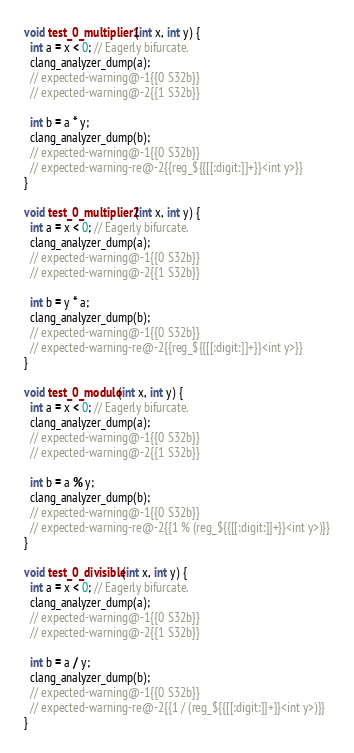<code> <loc_0><loc_0><loc_500><loc_500><_C_>void test_0_multiplier1(int x, int y) {
  int a = x < 0; // Eagerly bifurcate.
  clang_analyzer_dump(a);
  // expected-warning@-1{{0 S32b}}
  // expected-warning@-2{{1 S32b}}

  int b = a * y;
  clang_analyzer_dump(b);
  // expected-warning@-1{{0 S32b}}
  // expected-warning-re@-2{{reg_${{[[:digit:]]+}}<int y>}}
}

void test_0_multiplier2(int x, int y) {
  int a = x < 0; // Eagerly bifurcate.
  clang_analyzer_dump(a);
  // expected-warning@-1{{0 S32b}}
  // expected-warning@-2{{1 S32b}}

  int b = y * a;
  clang_analyzer_dump(b);
  // expected-warning@-1{{0 S32b}}
  // expected-warning-re@-2{{reg_${{[[:digit:]]+}}<int y>}}
}

void test_0_modulo(int x, int y) {
  int a = x < 0; // Eagerly bifurcate.
  clang_analyzer_dump(a);
  // expected-warning@-1{{0 S32b}}
  // expected-warning@-2{{1 S32b}}

  int b = a % y;
  clang_analyzer_dump(b);
  // expected-warning@-1{{0 S32b}}
  // expected-warning-re@-2{{1 % (reg_${{[[:digit:]]+}}<int y>)}}
}

void test_0_divisible(int x, int y) {
  int a = x < 0; // Eagerly bifurcate.
  clang_analyzer_dump(a);
  // expected-warning@-1{{0 S32b}}
  // expected-warning@-2{{1 S32b}}

  int b = a / y;
  clang_analyzer_dump(b);
  // expected-warning@-1{{0 S32b}}
  // expected-warning-re@-2{{1 / (reg_${{[[:digit:]]+}}<int y>)}}
}
</code> 